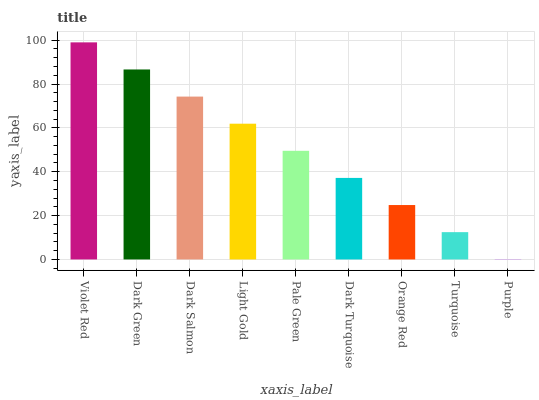Is Purple the minimum?
Answer yes or no. Yes. Is Violet Red the maximum?
Answer yes or no. Yes. Is Dark Green the minimum?
Answer yes or no. No. Is Dark Green the maximum?
Answer yes or no. No. Is Violet Red greater than Dark Green?
Answer yes or no. Yes. Is Dark Green less than Violet Red?
Answer yes or no. Yes. Is Dark Green greater than Violet Red?
Answer yes or no. No. Is Violet Red less than Dark Green?
Answer yes or no. No. Is Pale Green the high median?
Answer yes or no. Yes. Is Pale Green the low median?
Answer yes or no. Yes. Is Dark Green the high median?
Answer yes or no. No. Is Dark Green the low median?
Answer yes or no. No. 